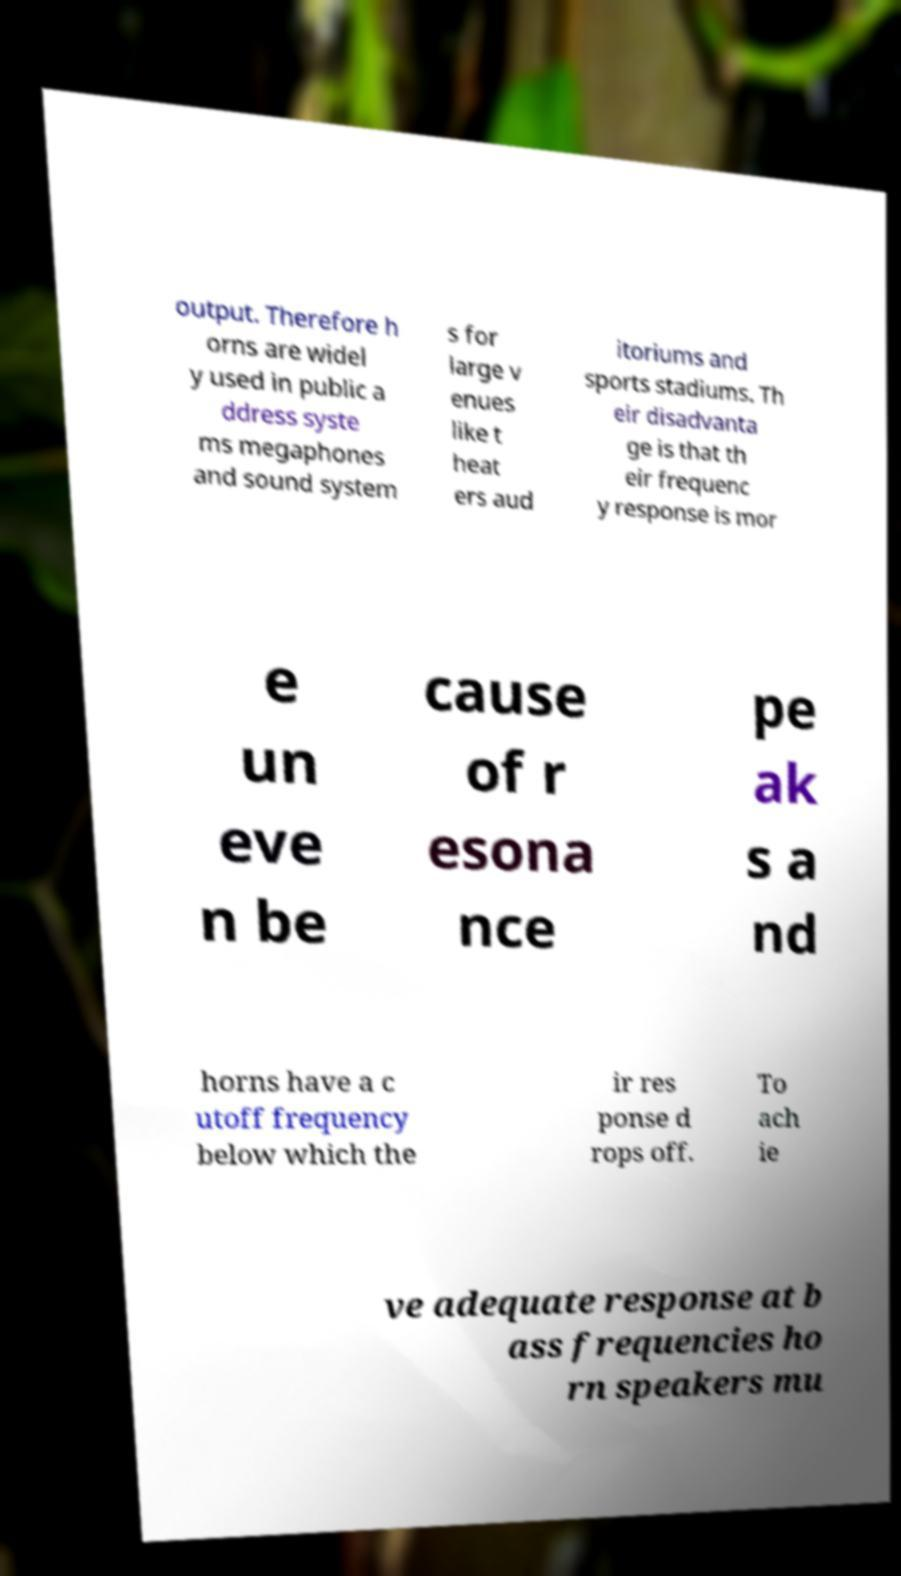For documentation purposes, I need the text within this image transcribed. Could you provide that? output. Therefore h orns are widel y used in public a ddress syste ms megaphones and sound system s for large v enues like t heat ers aud itoriums and sports stadiums. Th eir disadvanta ge is that th eir frequenc y response is mor e un eve n be cause of r esona nce pe ak s a nd horns have a c utoff frequency below which the ir res ponse d rops off. To ach ie ve adequate response at b ass frequencies ho rn speakers mu 